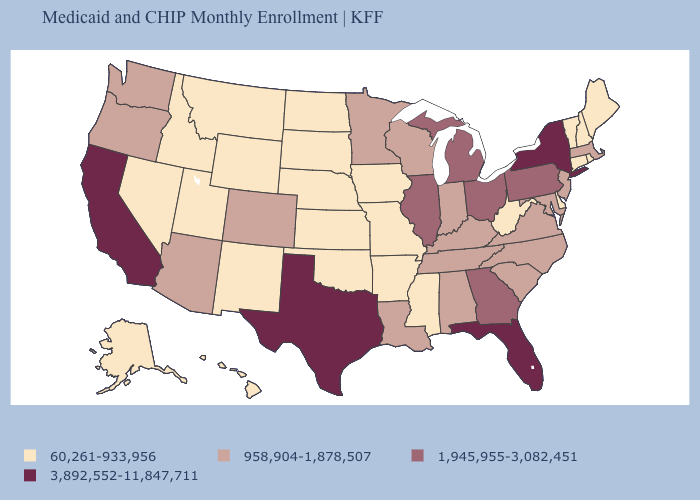Is the legend a continuous bar?
Quick response, please. No. Does Mississippi have the lowest value in the USA?
Quick response, please. Yes. What is the value of Idaho?
Concise answer only. 60,261-933,956. Among the states that border Massachusetts , which have the highest value?
Short answer required. New York. Name the states that have a value in the range 1,945,955-3,082,451?
Quick response, please. Georgia, Illinois, Michigan, Ohio, Pennsylvania. Name the states that have a value in the range 3,892,552-11,847,711?
Give a very brief answer. California, Florida, New York, Texas. Name the states that have a value in the range 958,904-1,878,507?
Short answer required. Alabama, Arizona, Colorado, Indiana, Kentucky, Louisiana, Maryland, Massachusetts, Minnesota, New Jersey, North Carolina, Oregon, South Carolina, Tennessee, Virginia, Washington, Wisconsin. What is the lowest value in the USA?
Answer briefly. 60,261-933,956. Does the map have missing data?
Quick response, please. No. Which states have the lowest value in the West?
Concise answer only. Alaska, Hawaii, Idaho, Montana, Nevada, New Mexico, Utah, Wyoming. Does Tennessee have the lowest value in the South?
Short answer required. No. Does Georgia have the same value as Wyoming?
Answer briefly. No. What is the value of Georgia?
Be succinct. 1,945,955-3,082,451. Does Montana have the lowest value in the USA?
Concise answer only. Yes. Which states hav the highest value in the West?
Answer briefly. California. 